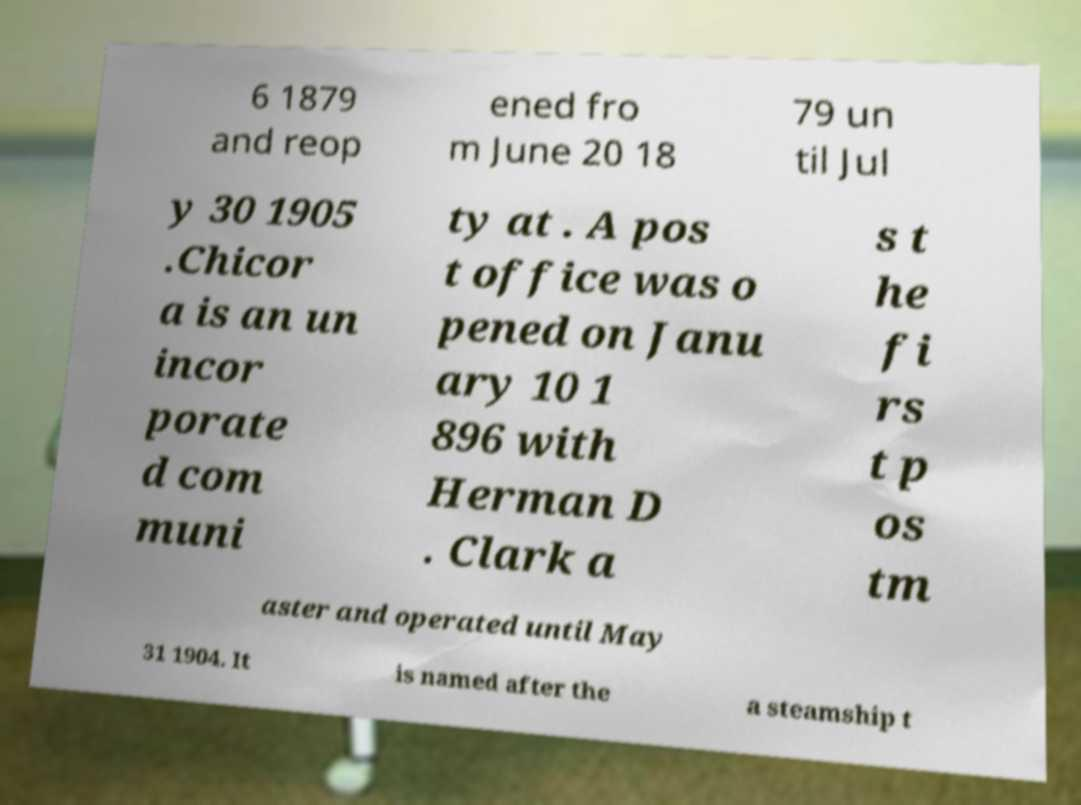Please identify and transcribe the text found in this image. 6 1879 and reop ened fro m June 20 18 79 un til Jul y 30 1905 .Chicor a is an un incor porate d com muni ty at . A pos t office was o pened on Janu ary 10 1 896 with Herman D . Clark a s t he fi rs t p os tm aster and operated until May 31 1904. It is named after the a steamship t 